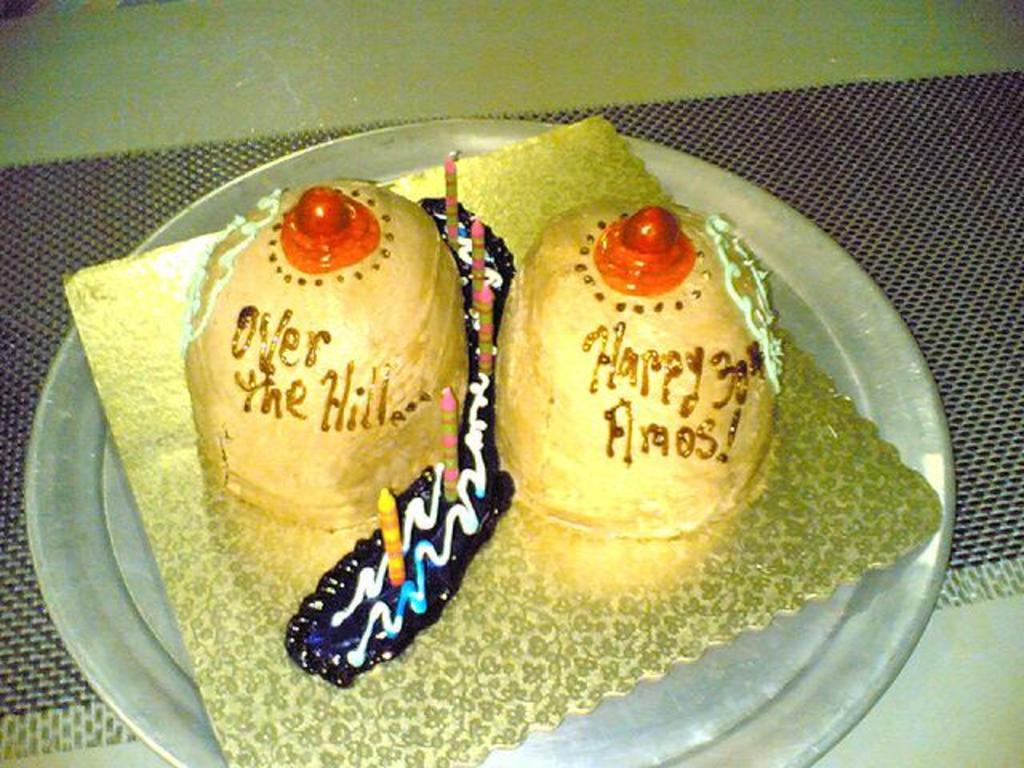What is on the serving plate in the image? The serving plate contains cake. What is on top of the cake? There are candles on the cake. Where is the serving plate located? The serving plate is placed on a table. What type of instrument is being played in the image? There is no instrument being played in the image; it only features a serving plate with cake and candles. 